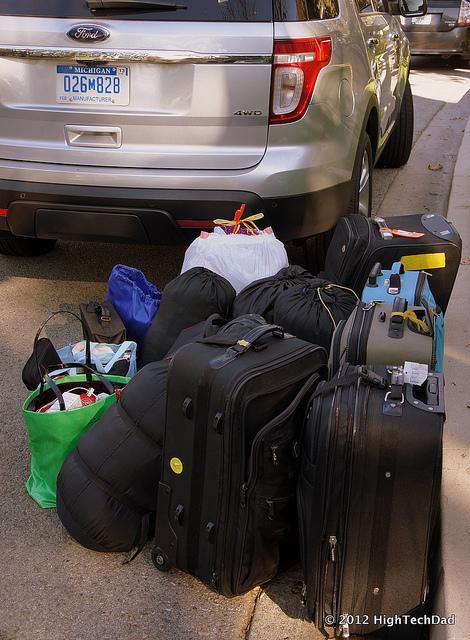How many pieces of luggage are shown?
Keep it brief. 8. Is the luggage going into the trunk of the car?
Be succinct. Yes. By looking at the luggage, how many people do you think are traveling in the vehicle?
Keep it brief. 4. Is it time for summer camp already?
Write a very short answer. Yes. Is the read door of the vehicle open?
Answer briefly. No. What is all of this sitting on the road?
Give a very brief answer. Luggage. Which bag is sky blue?
Concise answer only. Right. What color is the bag that isn't black?
Be succinct. Green. Are these suitcases waiting to be picked up?
Answer briefly. Yes. 